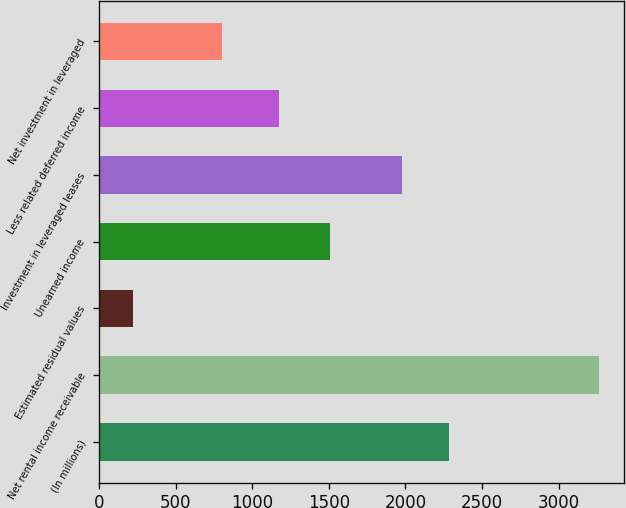Convert chart to OTSL. <chart><loc_0><loc_0><loc_500><loc_500><bar_chart><fcel>(In millions)<fcel>Net rental income receivable<fcel>Estimated residual values<fcel>Unearned income<fcel>Investment in leveraged leases<fcel>Less related deferred income<fcel>Net investment in leveraged<nl><fcel>2284.2<fcel>3264<fcel>222<fcel>1506<fcel>1980<fcel>1177<fcel>803<nl></chart> 